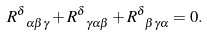Convert formula to latex. <formula><loc_0><loc_0><loc_500><loc_500>R ^ { \delta } _ { \ \alpha \beta \gamma } + R ^ { \delta } _ { \ \gamma \alpha \beta } + R ^ { \delta } _ { \ \beta \gamma \alpha } = 0 .</formula> 